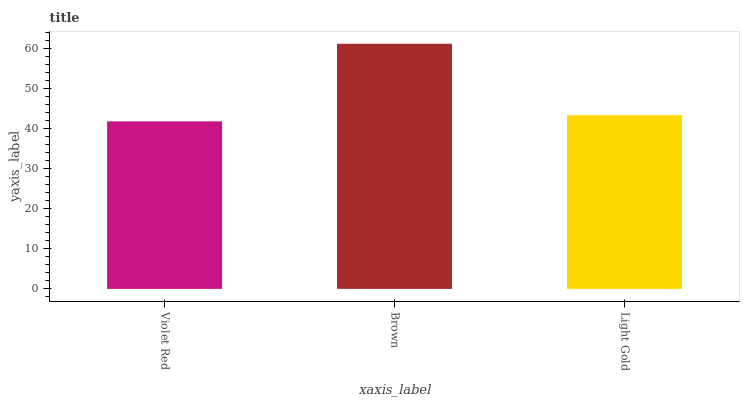Is Violet Red the minimum?
Answer yes or no. Yes. Is Brown the maximum?
Answer yes or no. Yes. Is Light Gold the minimum?
Answer yes or no. No. Is Light Gold the maximum?
Answer yes or no. No. Is Brown greater than Light Gold?
Answer yes or no. Yes. Is Light Gold less than Brown?
Answer yes or no. Yes. Is Light Gold greater than Brown?
Answer yes or no. No. Is Brown less than Light Gold?
Answer yes or no. No. Is Light Gold the high median?
Answer yes or no. Yes. Is Light Gold the low median?
Answer yes or no. Yes. Is Violet Red the high median?
Answer yes or no. No. Is Violet Red the low median?
Answer yes or no. No. 